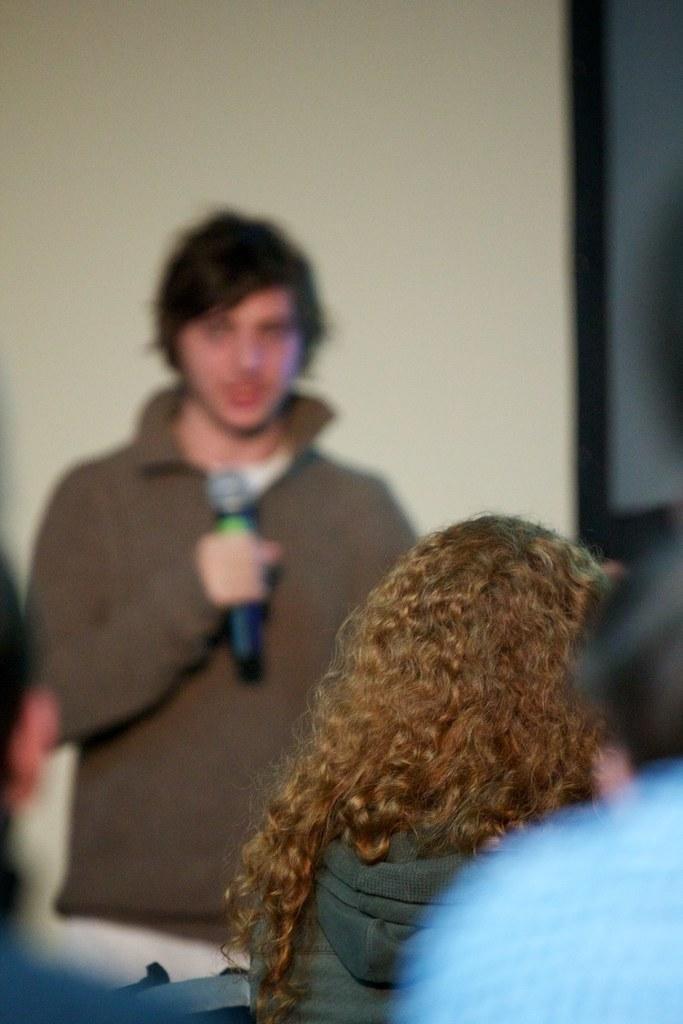Could you give a brief overview of what you see in this image? In this image there is a person standing and holding a mic. At the bottom there are people. In the background there is a wall. 